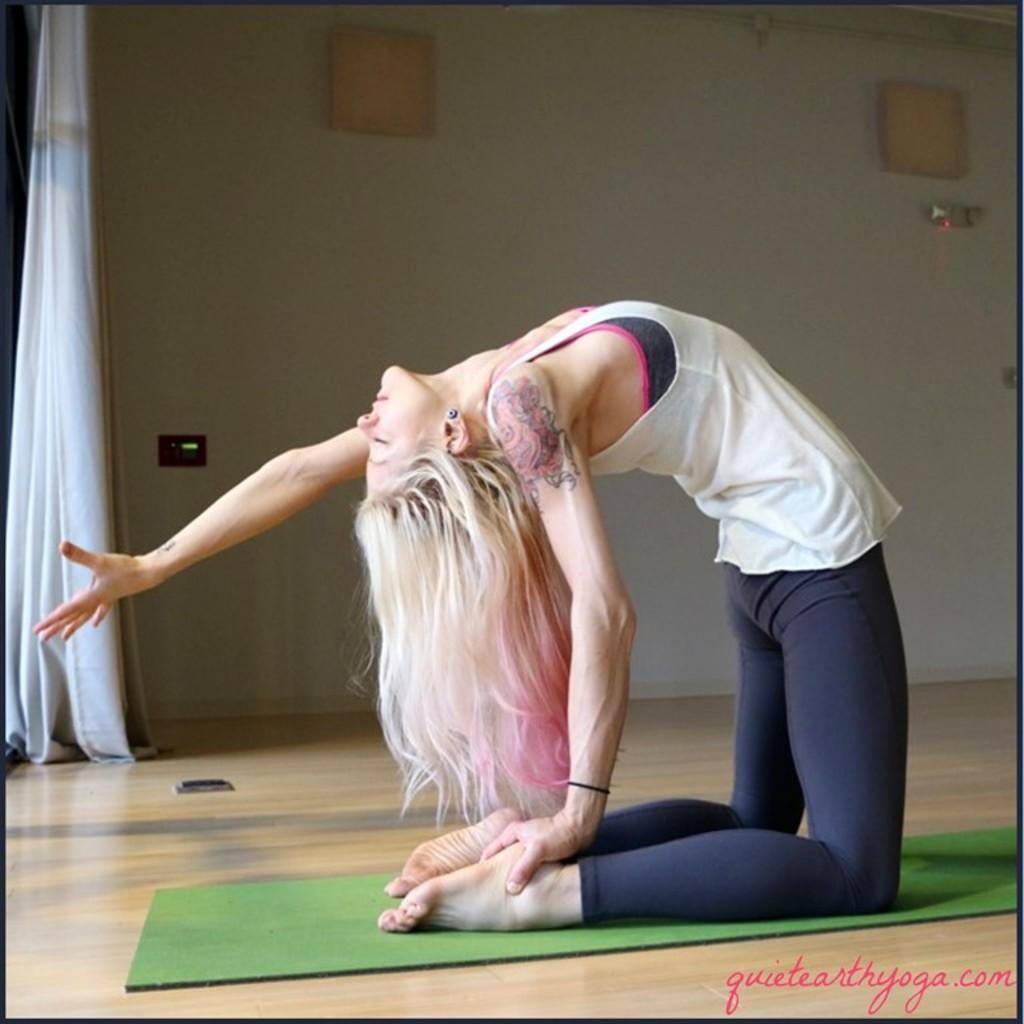Who is the main subject in the foreground of the picture? There is a woman in the foreground of the picture. What is the woman doing in the image? The woman is doing exercise on a mat. What can be seen in the background of the picture? There is a wall and a curtain in the background of the picture. What type of mine is visible in the background of the picture? There is no mine present in the background of the picture. Can you tell me how many pets are in the image? There are no pets visible in the image. 